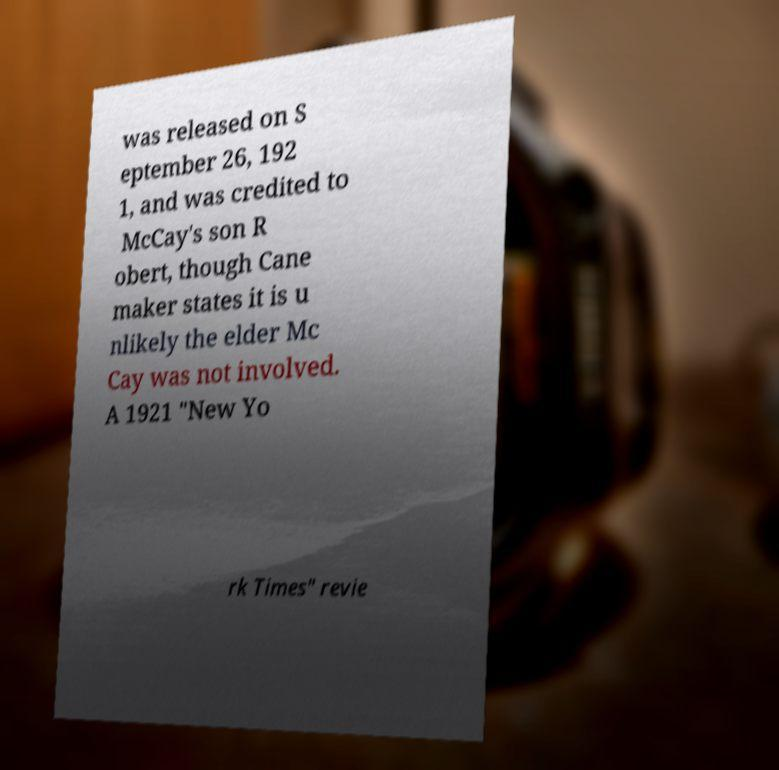Please identify and transcribe the text found in this image. was released on S eptember 26, 192 1, and was credited to McCay's son R obert, though Cane maker states it is u nlikely the elder Mc Cay was not involved. A 1921 "New Yo rk Times" revie 